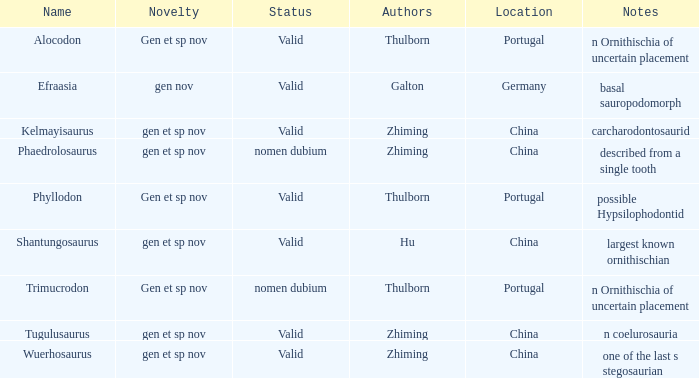What is the Novelty of the dinosaur, whose naming Author was Galton? Gen nov. 